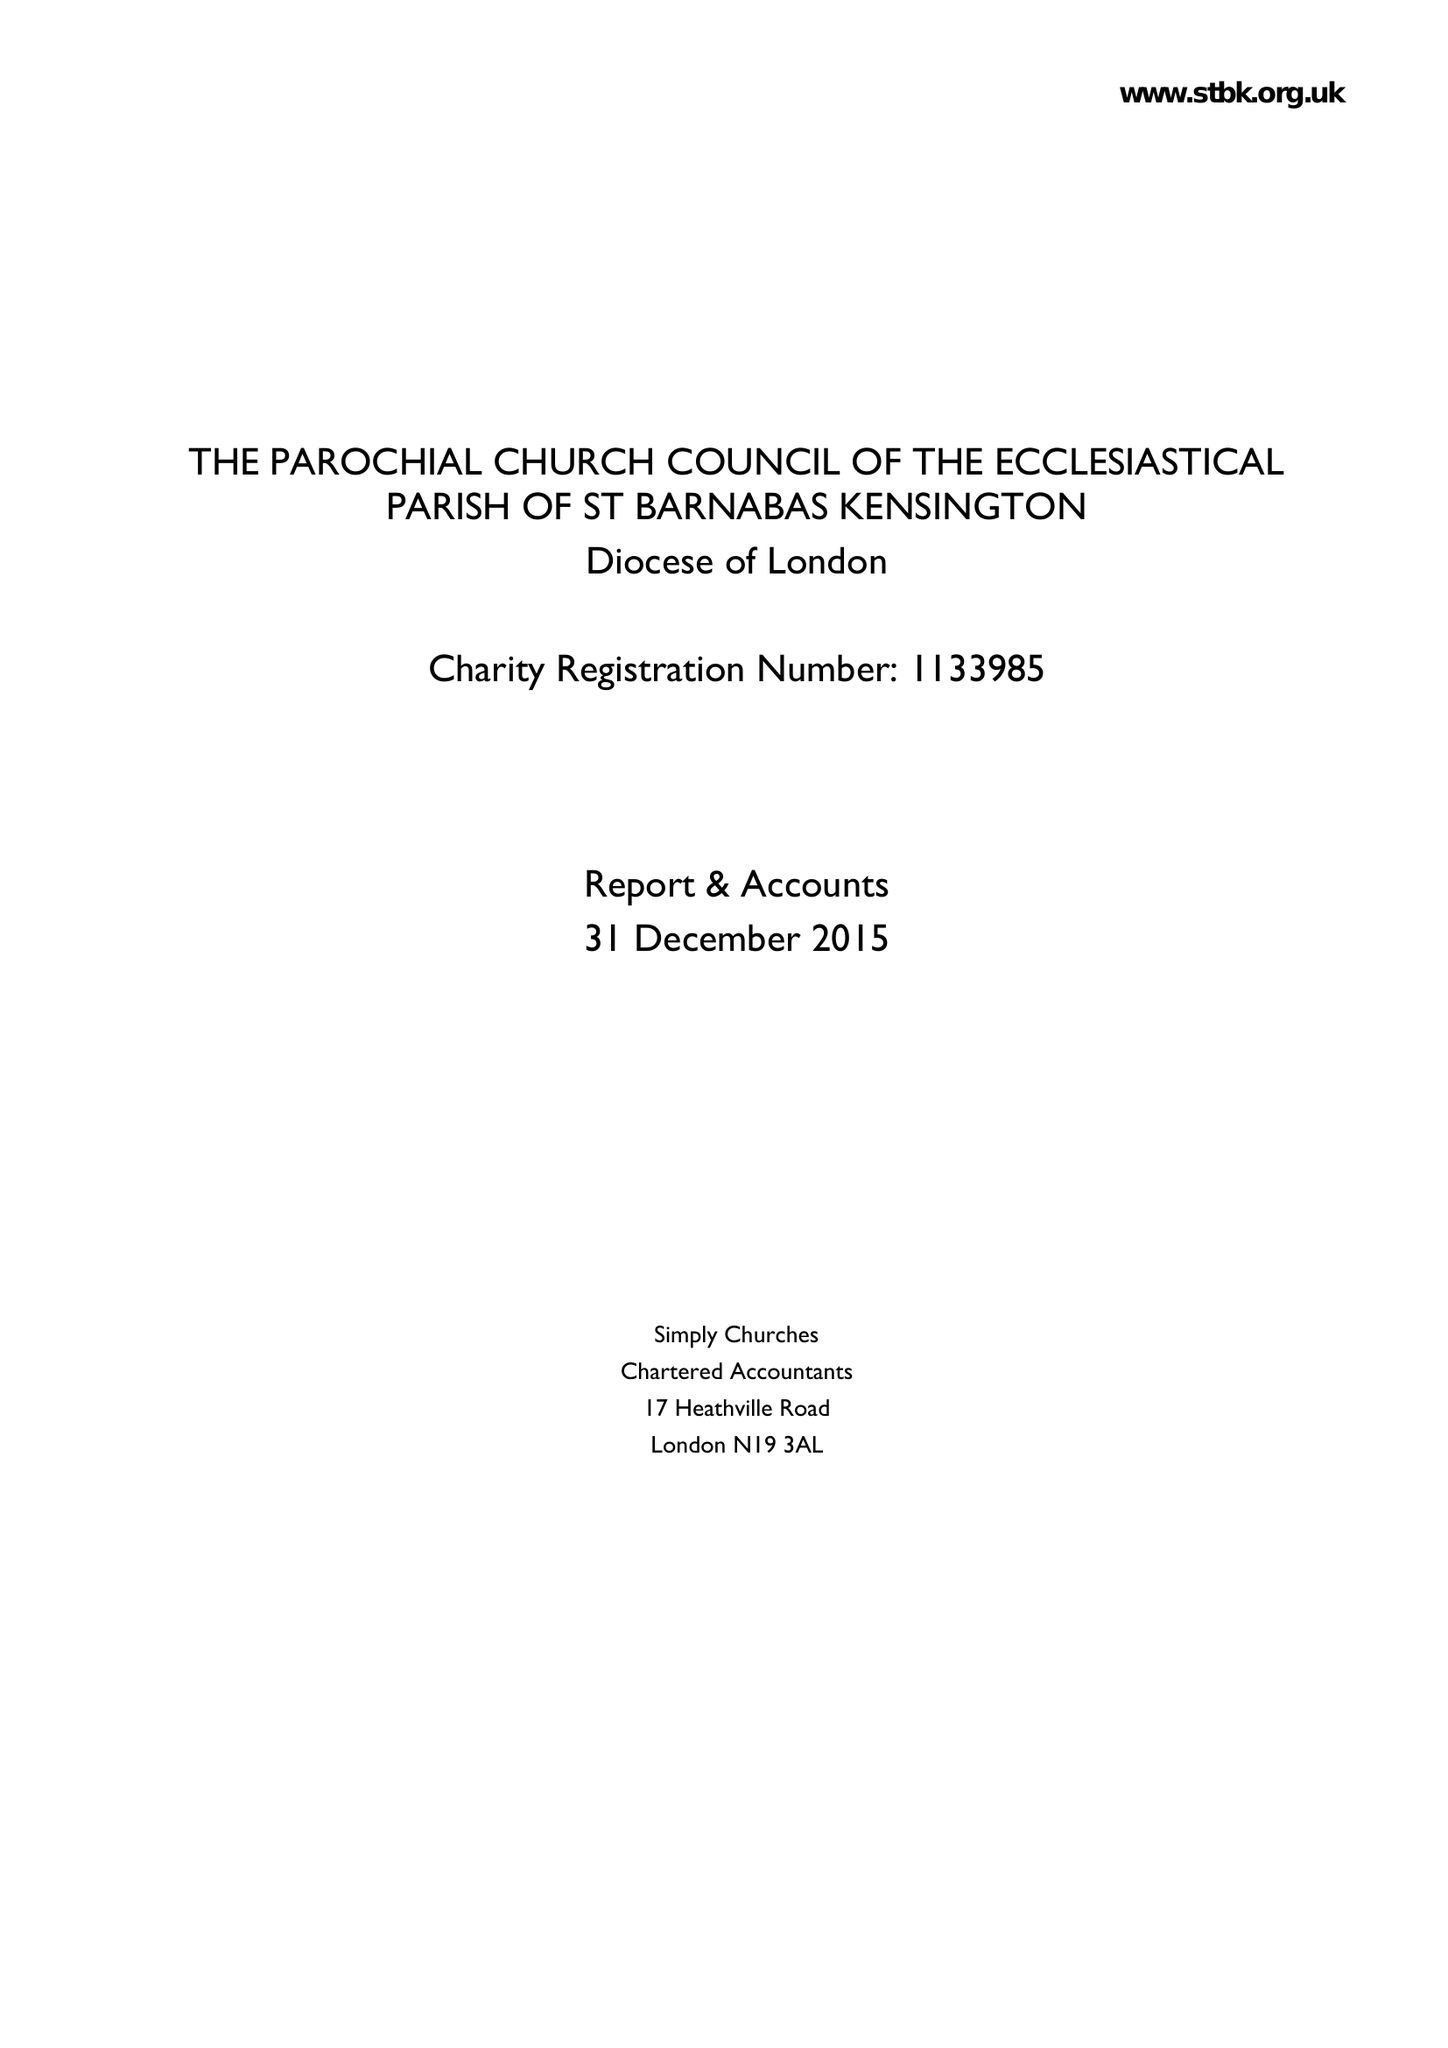What is the value for the income_annually_in_british_pounds?
Answer the question using a single word or phrase. 491195.00 